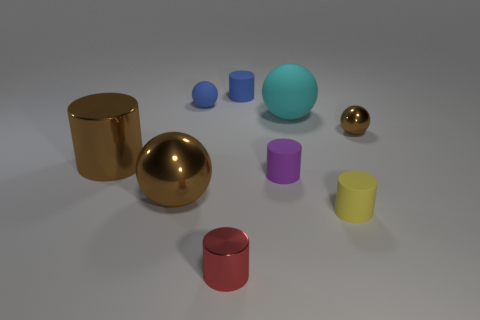The other matte object that is the same shape as the large cyan rubber thing is what color?
Provide a succinct answer. Blue. Is there any other thing that is the same shape as the big cyan rubber object?
Give a very brief answer. Yes. Are there an equal number of cyan matte spheres that are to the left of the small metallic cylinder and big cyan cubes?
Your answer should be compact. Yes. There is a red shiny thing; are there any brown spheres in front of it?
Give a very brief answer. No. There is a blue rubber object left of the tiny blue cylinder behind the large ball behind the purple matte cylinder; what size is it?
Keep it short and to the point. Small. There is a blue matte thing to the left of the red cylinder; is it the same shape as the shiny object right of the yellow object?
Provide a succinct answer. Yes. There is another rubber thing that is the same shape as the large cyan thing; what size is it?
Provide a succinct answer. Small. How many blue balls are the same material as the small purple object?
Provide a short and direct response. 1. What is the tiny brown thing made of?
Your answer should be compact. Metal. What shape is the small shiny object to the right of the large cyan rubber object that is in front of the tiny blue ball?
Make the answer very short. Sphere. 